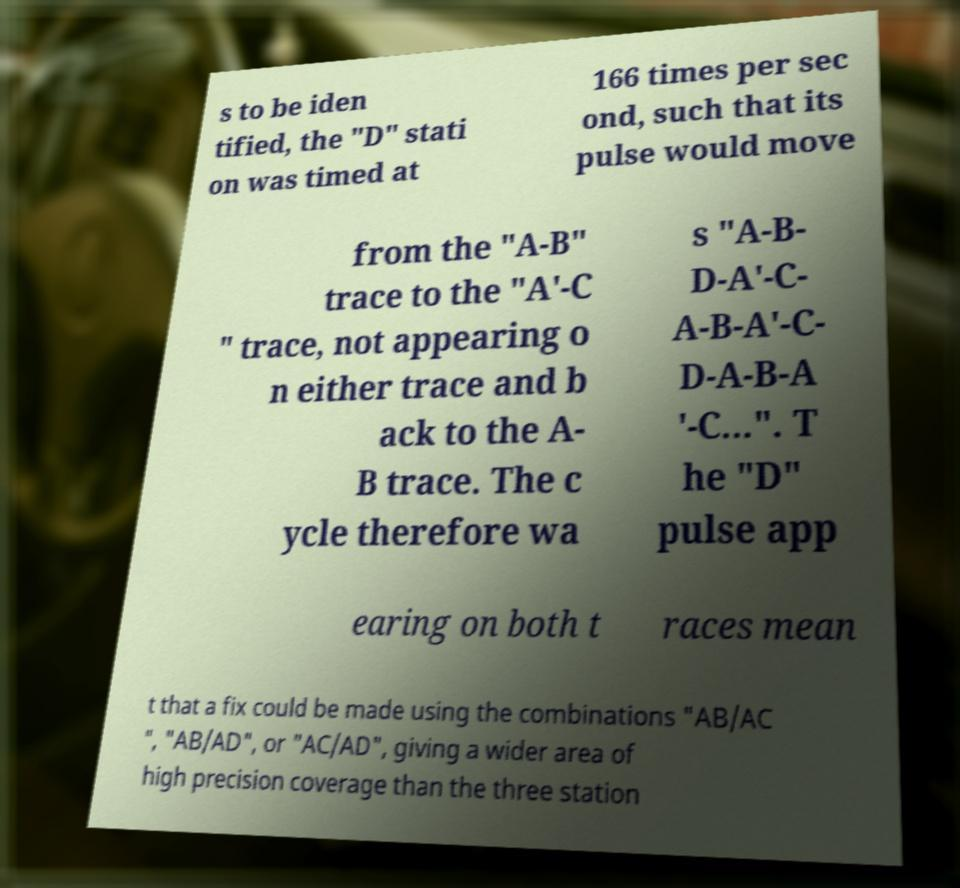What messages or text are displayed in this image? I need them in a readable, typed format. s to be iden tified, the "D" stati on was timed at 166 times per sec ond, such that its pulse would move from the "A-B" trace to the "A'-C " trace, not appearing o n either trace and b ack to the A- B trace. The c ycle therefore wa s "A-B- D-A′-C- A-B-A′-C- D-A-B-A ′-C...". T he "D" pulse app earing on both t races mean t that a fix could be made using the combinations "AB/AC ", "AB/AD", or "AC/AD", giving a wider area of high precision coverage than the three station 